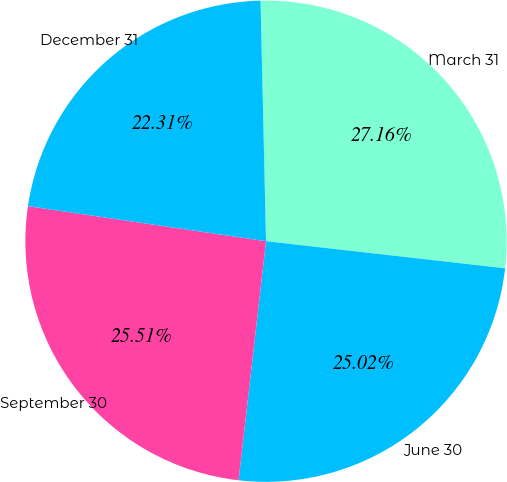Convert chart. <chart><loc_0><loc_0><loc_500><loc_500><pie_chart><fcel>March 31<fcel>June 30<fcel>September 30<fcel>December 31<nl><fcel>27.16%<fcel>25.02%<fcel>25.51%<fcel>22.31%<nl></chart> 